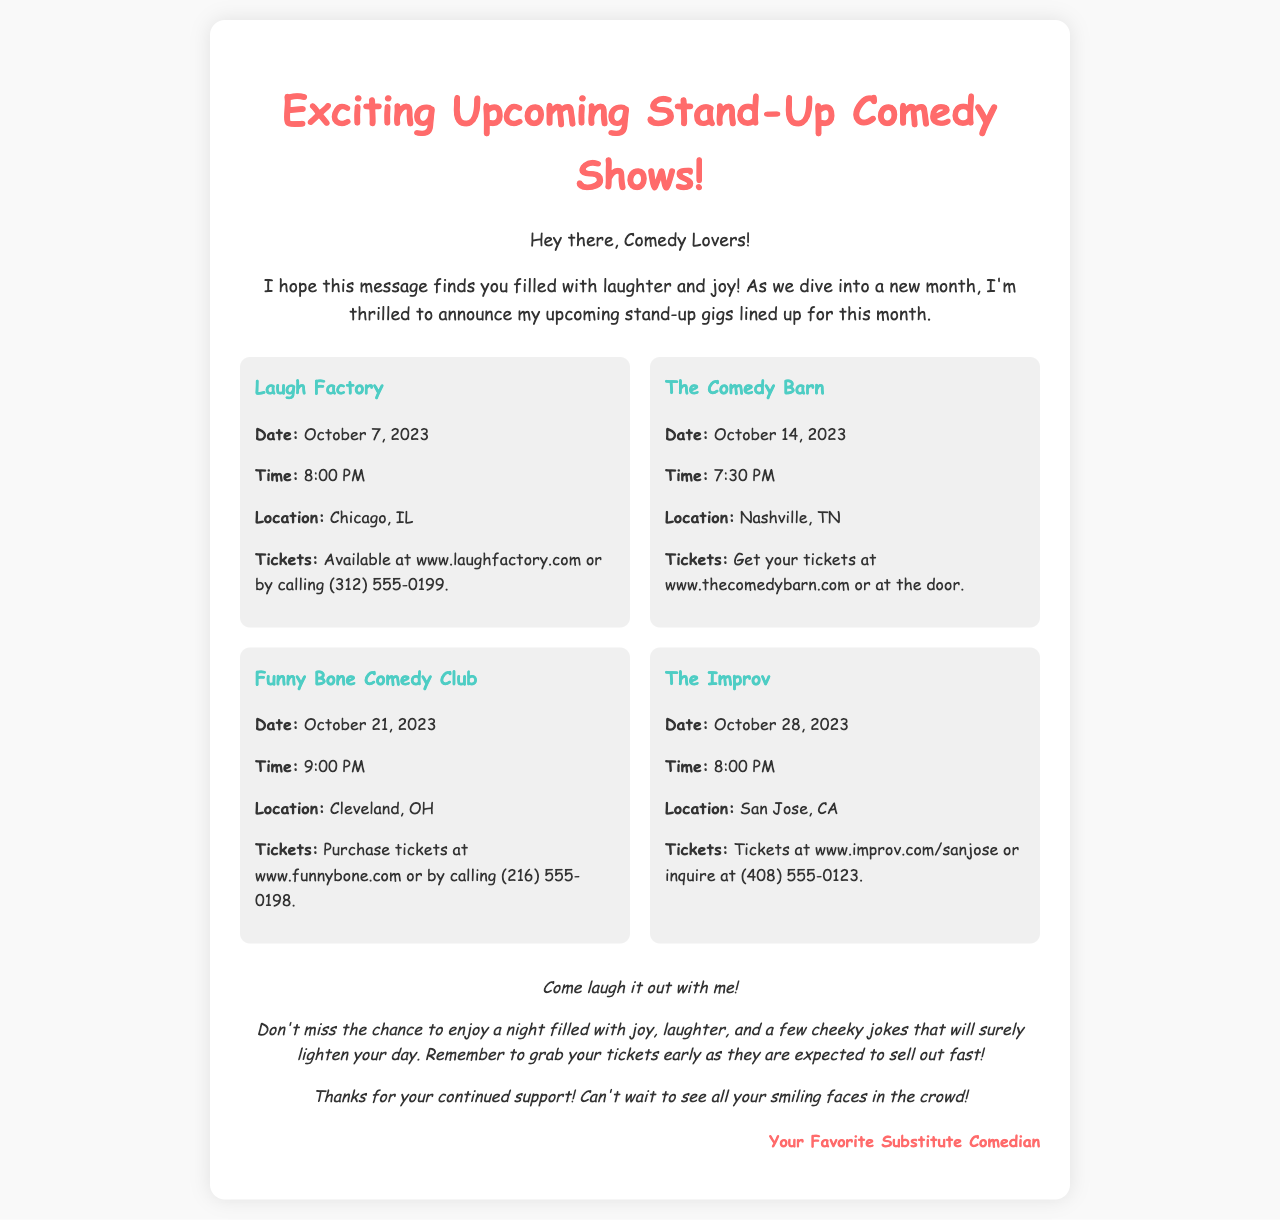What is the date of the Laugh Factory show? The date for the Laugh Factory show is explicitly mentioned in the document.
Answer: October 7, 2023 What time does The Comedy Barn show start? The document specifies the start time of The Comedy Barn show.
Answer: 7:30 PM Where is the Funny Bone Comedy Club located? The location of the Funny Bone Comedy Club is clearly stated in the document.
Answer: Cleveland, OH How can tickets be purchased for The Improv? The document lists the ticket purchasing options for The Improv.
Answer: www.improv.com/sanjose or (408) 555-0123 Which show is scheduled last this month? This requires reasoning by comparing the dates given for the shows listed in the document.
Answer: The Improv What is the common theme of this document? The main theme is hinted at in the introduction paragraph of the document.
Answer: Upcoming stand-up comedy shows Who is the signature for the letter? The signature at the end of the document identifies the writer.
Answer: Your Favorite Substitute Comedian What is the color of the title text? The document specifies the color used for the title text in the styling section.
Answer: #ff6b6b What does the introduction encourage the audience to feel? The introduction expresses sentiments aimed at the audience's emotional experience.
Answer: Laughter and joy 